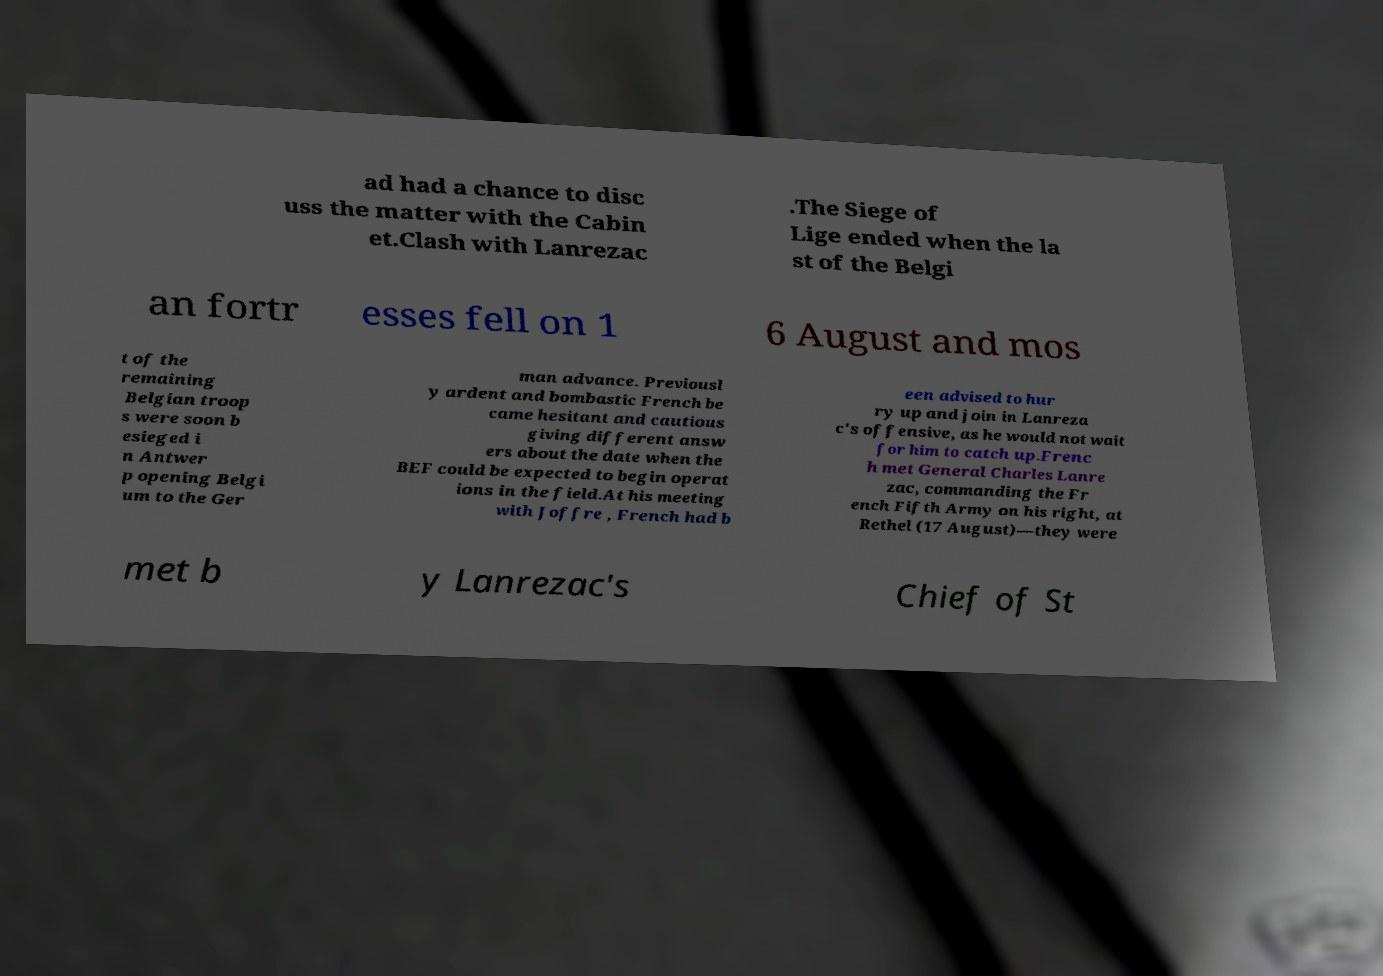Please identify and transcribe the text found in this image. ad had a chance to disc uss the matter with the Cabin et.Clash with Lanrezac .The Siege of Lige ended when the la st of the Belgi an fortr esses fell on 1 6 August and mos t of the remaining Belgian troop s were soon b esieged i n Antwer p opening Belgi um to the Ger man advance. Previousl y ardent and bombastic French be came hesitant and cautious giving different answ ers about the date when the BEF could be expected to begin operat ions in the field.At his meeting with Joffre , French had b een advised to hur ry up and join in Lanreza c's offensive, as he would not wait for him to catch up.Frenc h met General Charles Lanre zac, commanding the Fr ench Fifth Army on his right, at Rethel (17 August)—they were met b y Lanrezac's Chief of St 